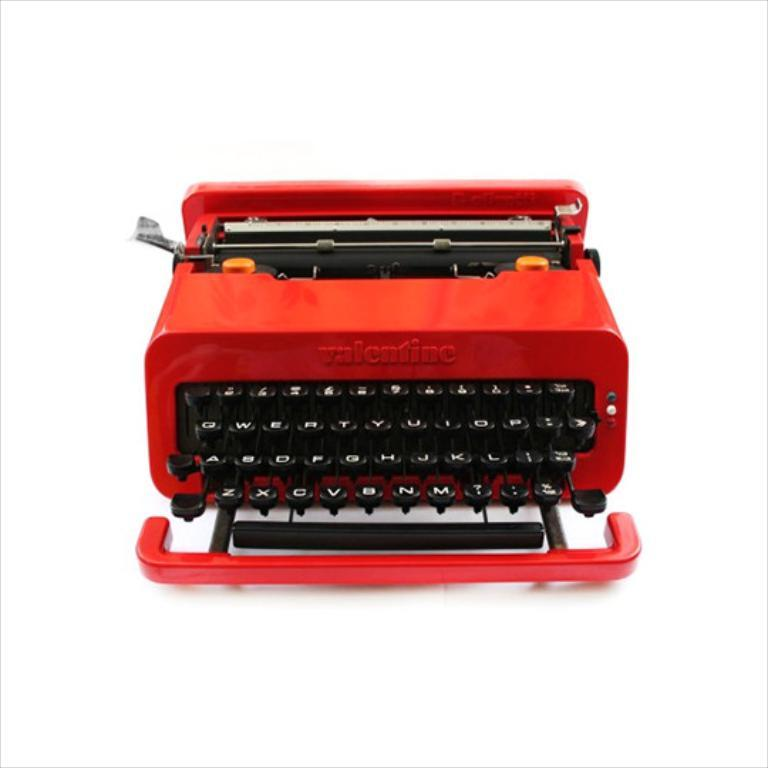<image>
Share a concise interpretation of the image provided. A red Valentine typewriter against a white back drop. 